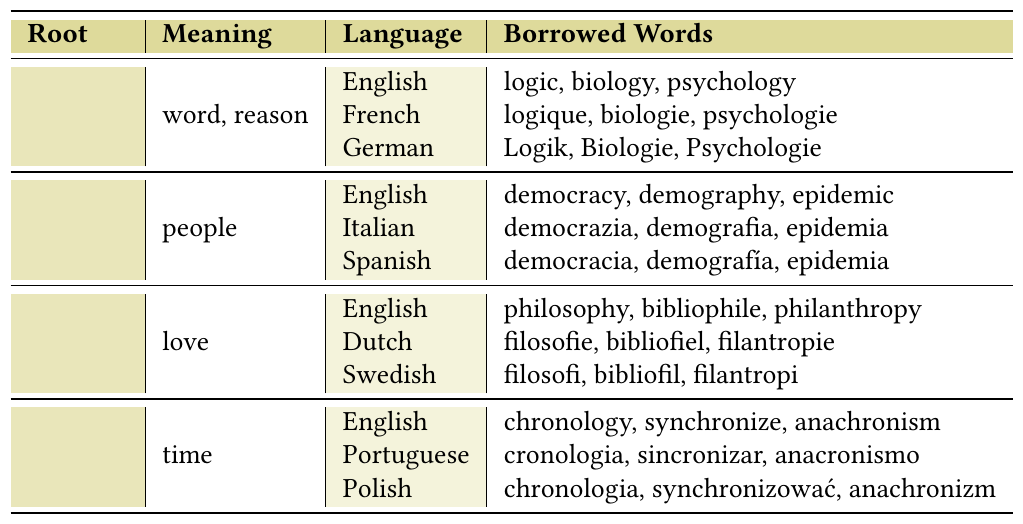What is the meaning of the root "logos"? According to the table, "logos" means "word, reason."
Answer: word, reason In which languages can we find borrowed words from the root "demos"? The table shows that borrowed words from "demos" can be found in English, Italian, and Spanish.
Answer: English, Italian, Spanish How many borrowed words are listed for the root "philia" in English? The table indicates that there are three borrowed words listed for "philia" in English: philosophy, bibliophile, and philanthropy.
Answer: 3 Which root word has borrowed terms in both English and Dutch? The table shows that "philia" has borrowed terms in both English (philosophy, bibliophile, philanthropy) and Dutch (filosofie, bibliofiel, filantropie).
Answer: philia Are there any borrowed words from the root "chronos" in Polish? Yes, the table confirms that there are borrowed words from the root "chronos" in Polish: chronologia, synchronizować, and anachronizm.
Answer: Yes What borrowed words from "logos" are present in German? The borrowed words in German from "logos" are Logik, Biologie, and Psychologie, as per the table.
Answer: Logik, Biologie, Psychologie How many roots are listed in total in the table? The table lists four root words: logos, demos, philia, and chronos. Counting them gives a total of four.
Answer: 4 Which root word has the meaning "people" and in how many languages does it appear? The root word "demos" means "people," and it appears in three languages: English, Italian, and Spanish.
Answer: demos, 3 If I were to summarize the borrowed words for "chronos" in English, what would I include? The borrowed words for "chronos" in English are chronology, synchronize, and anachronism, as found in the table.
Answer: chronology, synchronize, anachronism Which root has the borrowed word "demographia" in Italian? The borrowed word "demografia" in Italian comes from the root "demos," which means "people," seen in the table.
Answer: demos 